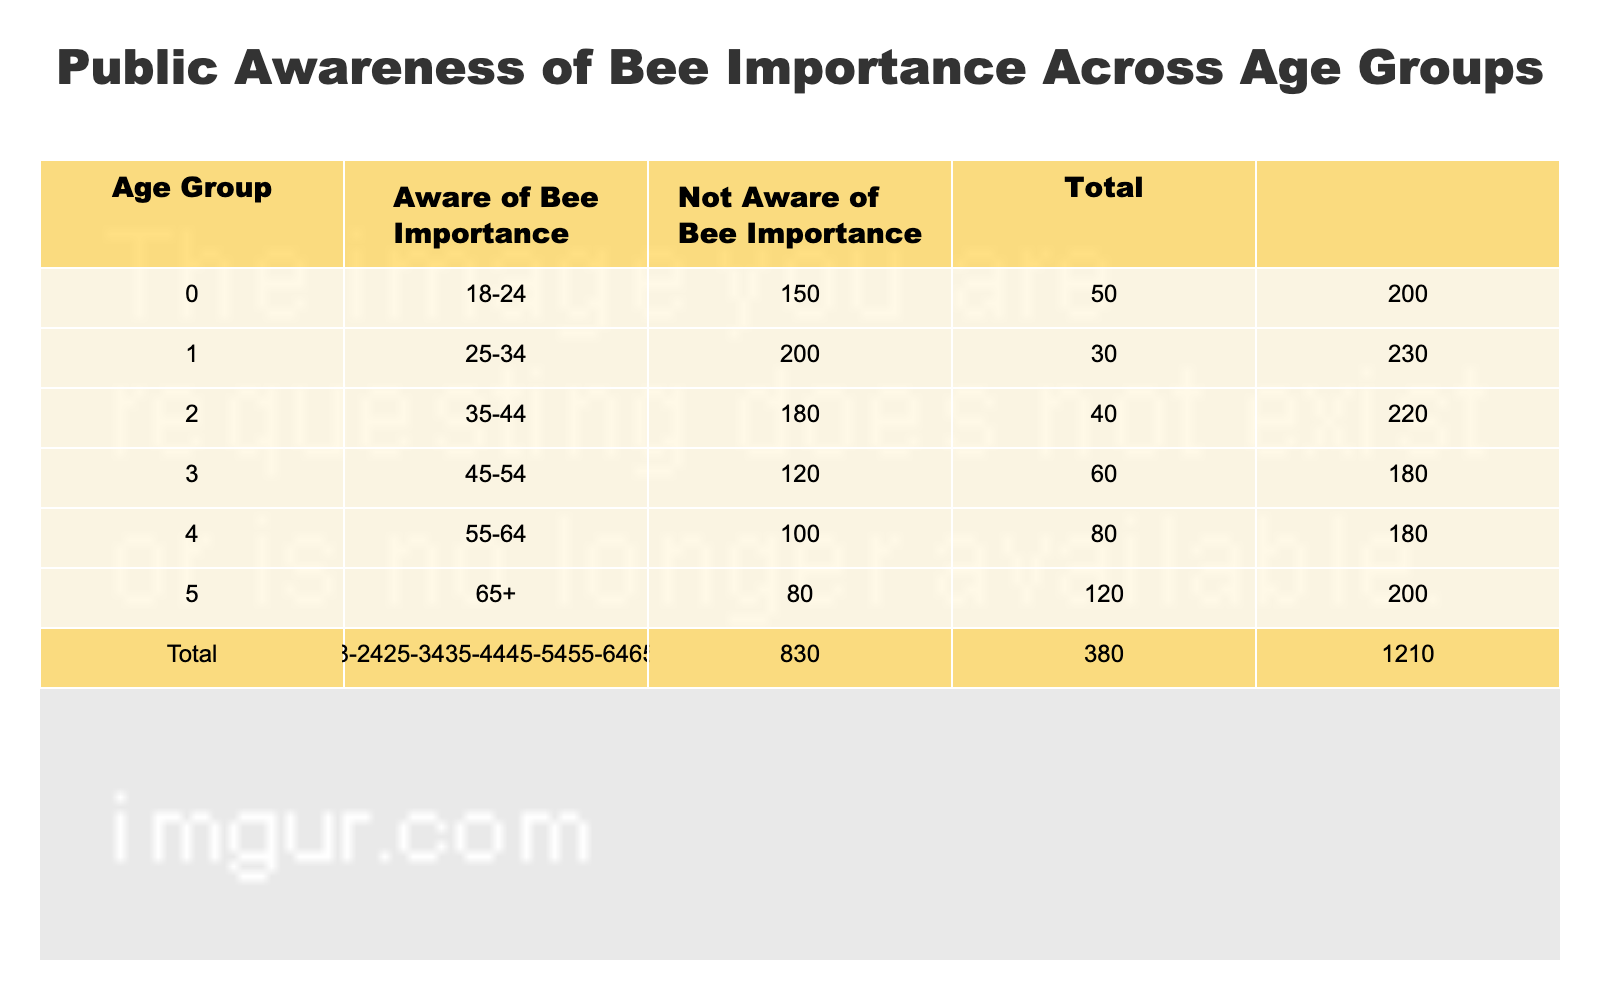What is the total number of people who are aware of bee importance in the age group 25-34? The table shows that in the age group 25-34, the number of people aware of bee importance is listed as 200.
Answer: 200 How many people in the age group 65+ are not aware of the importance of bees? According to the table, the number of people in the age group 65+ who are not aware of bee importance is 120.
Answer: 120 What is the age group with the highest number of people aware of bee importance? By examining the "Aware of Bee Importance" column, the age group 25-34 has the highest value at 200. Thus, the age group with the highest awareness is 25-34.
Answer: 25-34 In terms of people not aware, which age group has the least number of individuals? The minimum value in the "Not Aware of Bee Importance" column can be determined by checking each group. The lowest number is 30 from the age group 25-34.
Answer: 25-34 What is the difference in the number of aware individuals between the 18-24 and 55-64 age groups? The number of aware individuals in the 18-24 age group is 150, while in the 55-64 age group it is 100. The difference is calculated by 150 - 100, resulting in 50.
Answer: 50 What is the total number of individuals across all age groups who are aware of bee importance? Summing the "Aware of Bee Importance" values: 150 + 200 + 180 + 120 + 100 + 80 = 1020. Therefore, the total number is 1020.
Answer: 1020 Is it true that the age group with the most individuals not aware of bee importance (65+) has more individuals not aware than aware? In the age group 65+, there are 120 individuals not aware and 80 individuals aware. Since 120 is greater than 80, the statement is true.
Answer: Yes Which age group has the smallest total of individuals? To find the smallest total, we need to check the "Total" for each group: 200 (18-24), 230 (25-34), 220 (35-44), 180 (45-54), 180 (55-64), and 200 (65+). The smallest total is 180 from the age groups 45-54 and 55-64.
Answer: 45-54, 55-64 What percentage of the 35-44 age group is aware of bee importance? The total for the 35-44 age group is 220 (180 aware + 40 not aware). The percentage aware is calculated as (180/220) * 100 = 81.82%, which rounds to approximately 82%.
Answer: 82% 